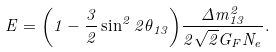<formula> <loc_0><loc_0><loc_500><loc_500>E = { \left ( 1 - \frac { 3 } { 2 } \sin ^ { 2 } 2 \theta _ { 1 3 } \right ) } \frac { \Delta m ^ { 2 } _ { 1 3 } } { 2 \sqrt { 2 } G _ { F } N _ { e } } .</formula> 